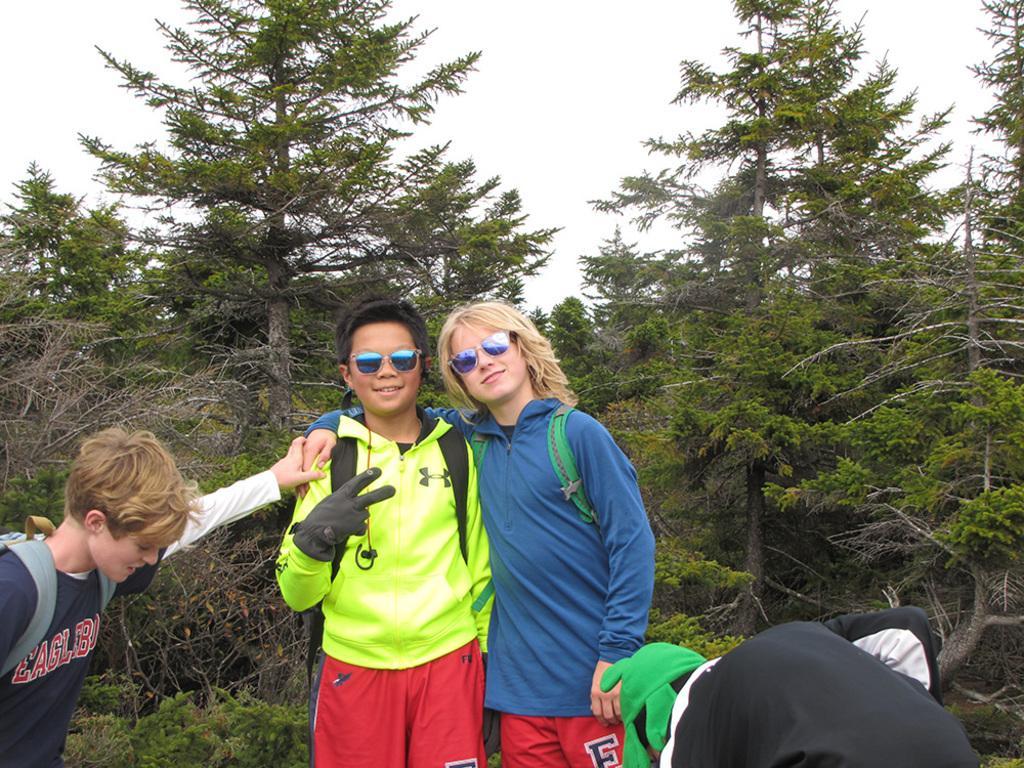Could you give a brief overview of what you see in this image? In this image we can see few people, two of them are with goggles, and three of them are wearing backpacks and there are few trees and the sky in the background. 